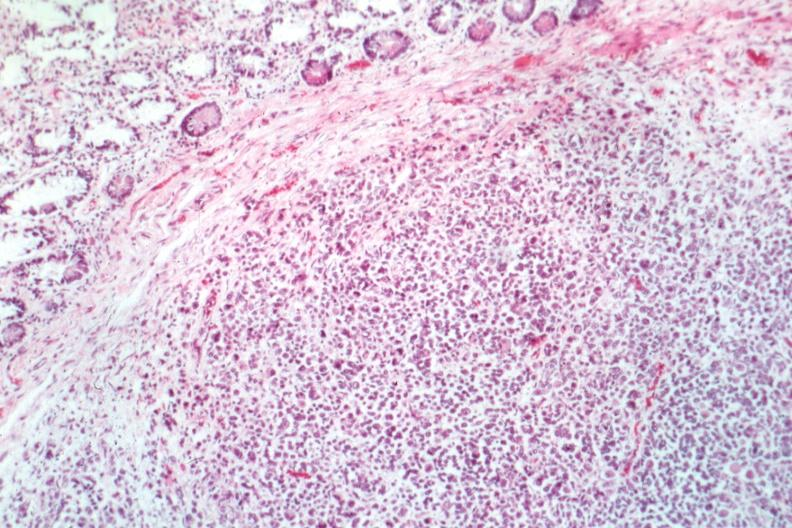s atrophy present?
Answer the question using a single word or phrase. No 